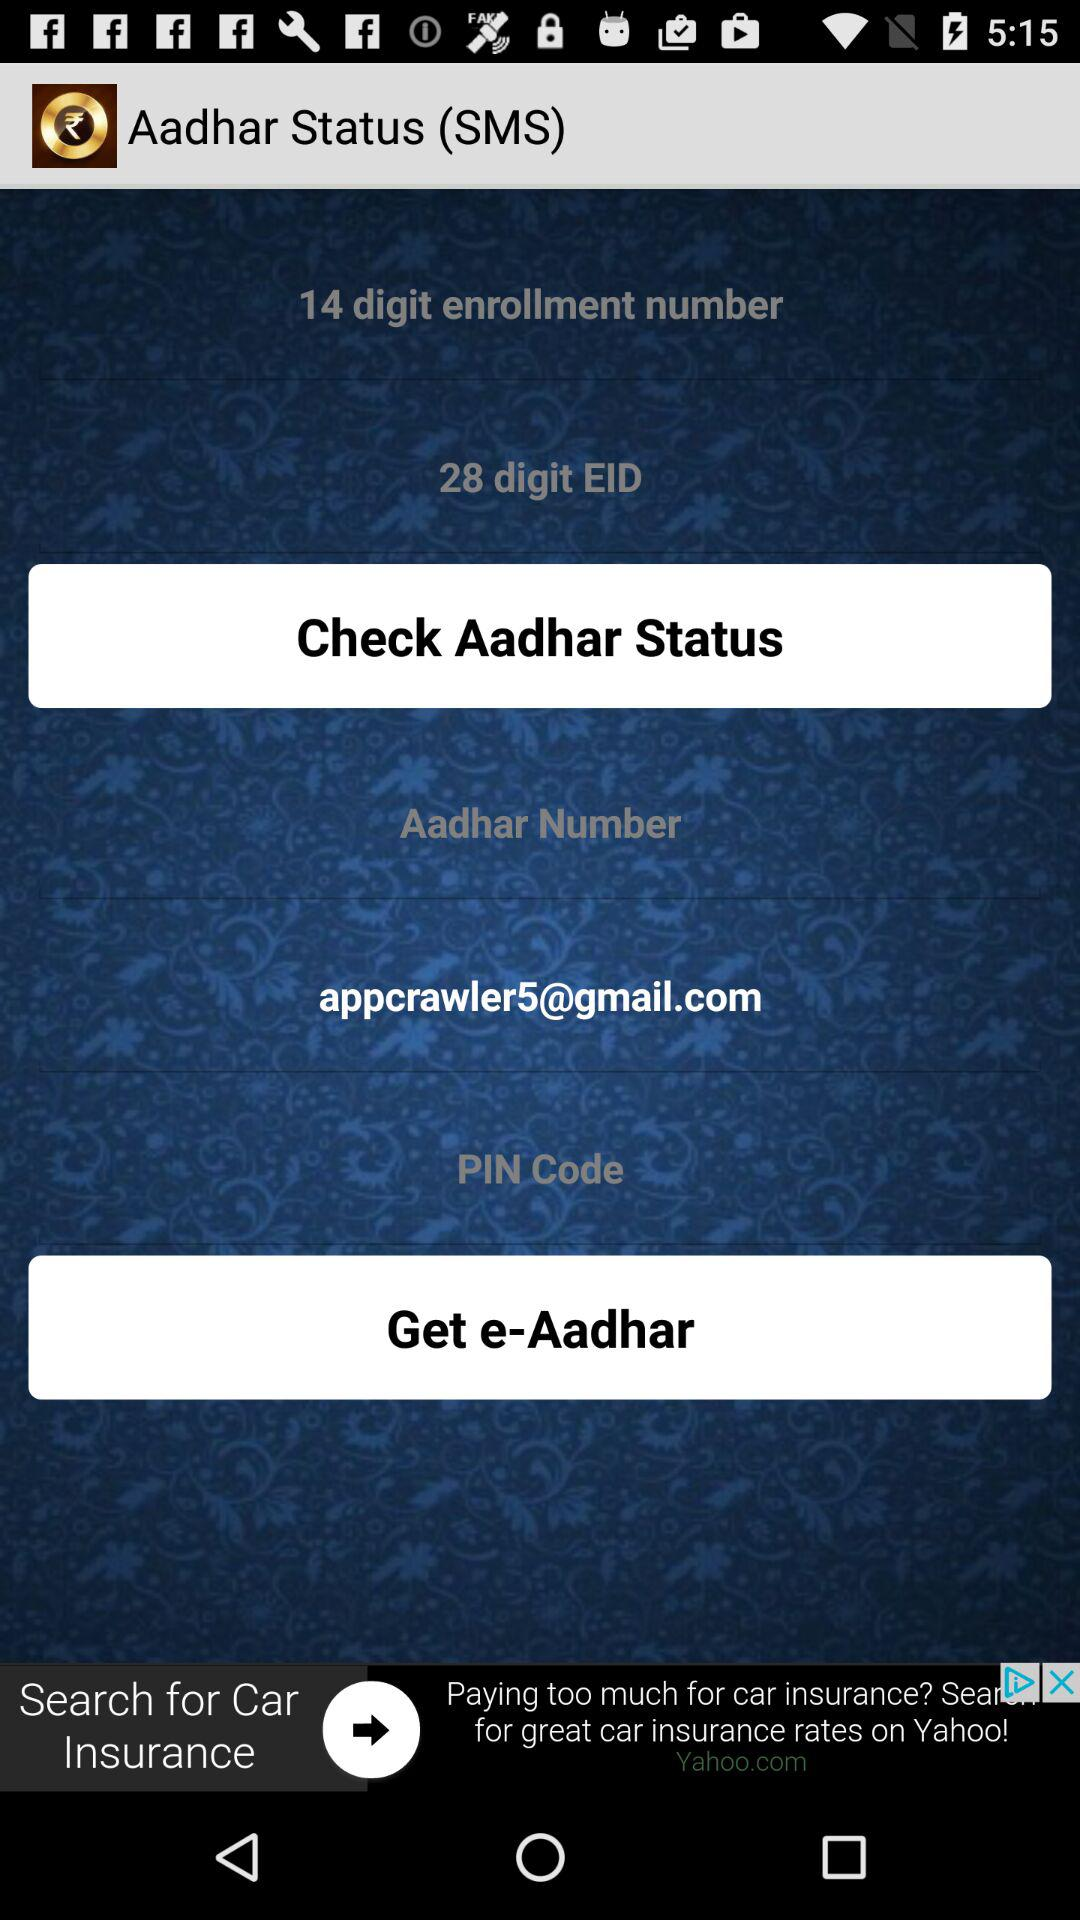What is the enrollment number's digit count? The enrollment number's digit count is 14. 